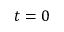<formula> <loc_0><loc_0><loc_500><loc_500>t = 0</formula> 